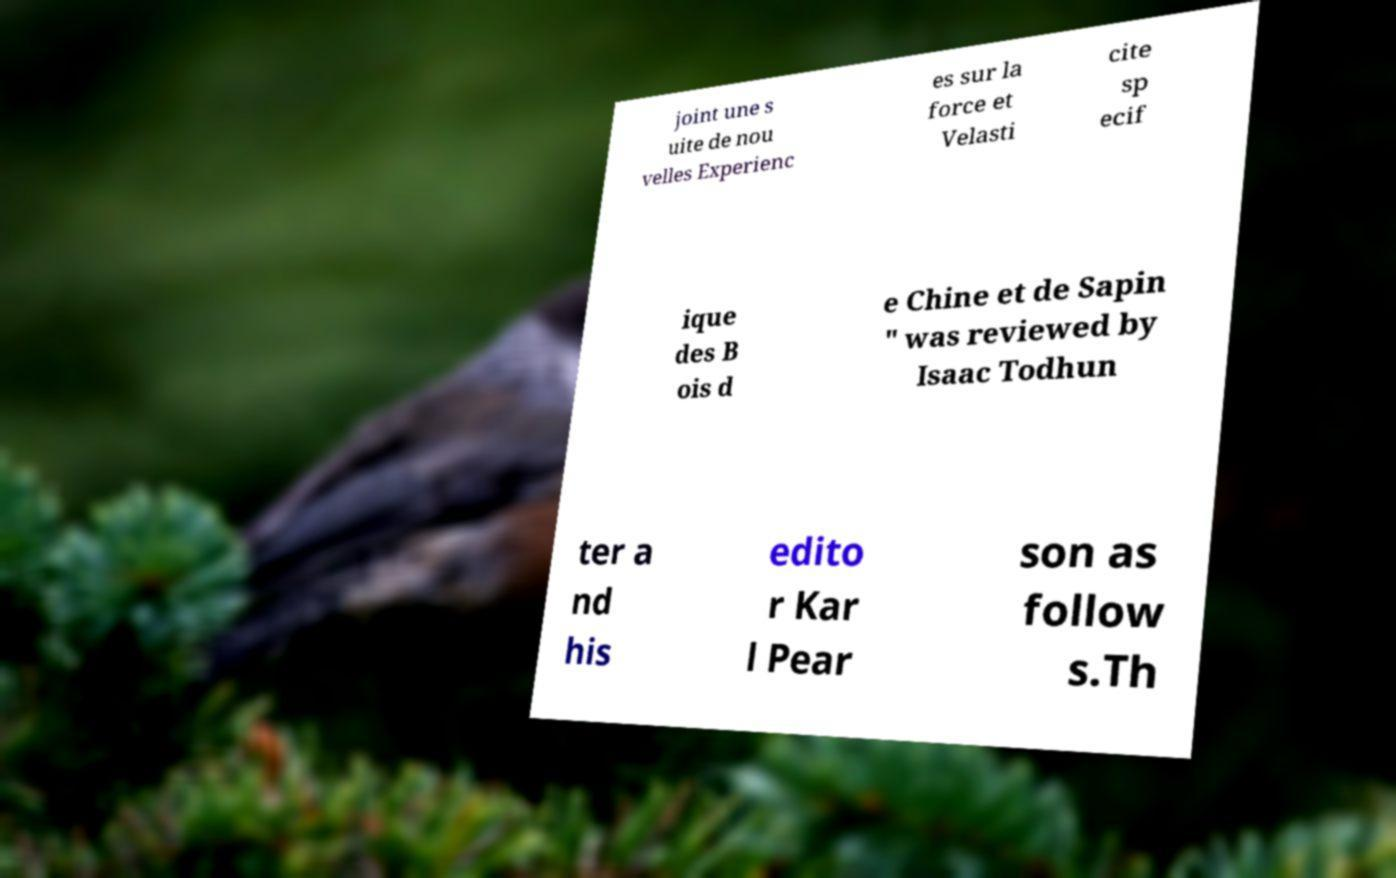Can you accurately transcribe the text from the provided image for me? joint une s uite de nou velles Experienc es sur la force et Velasti cite sp ecif ique des B ois d e Chine et de Sapin " was reviewed by Isaac Todhun ter a nd his edito r Kar l Pear son as follow s.Th 